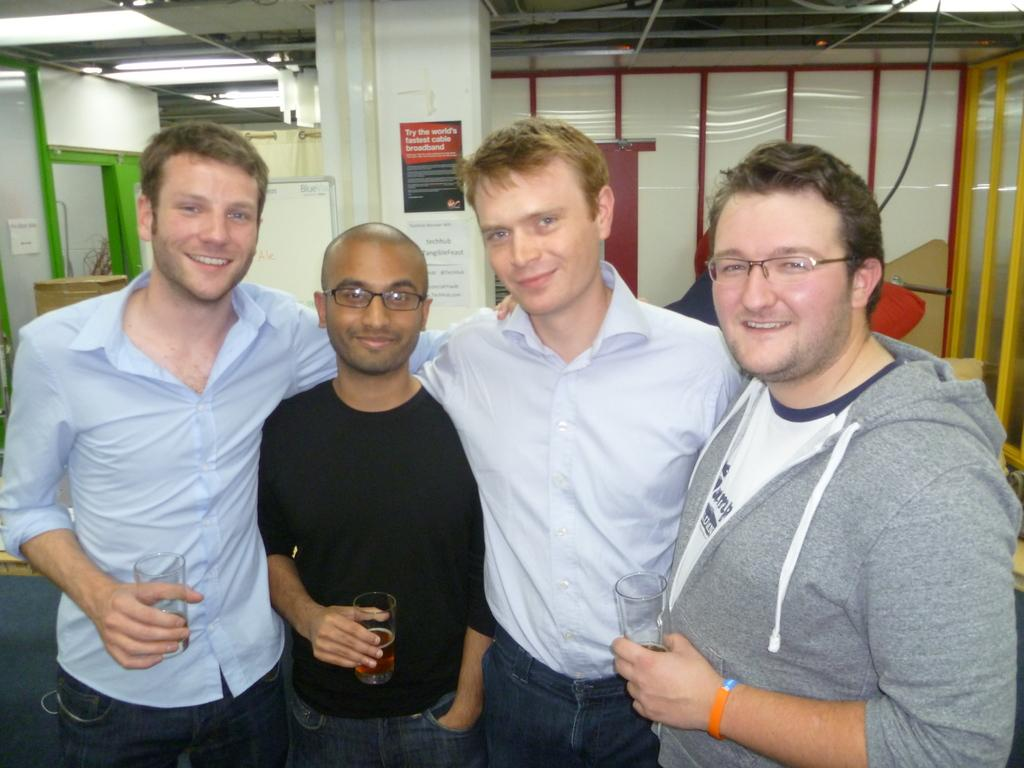What is the main subject of the image? The main subject of the image is a group of men. What are the men doing in the image? The men are standing in the image. What are the men holding in their hands? The men are holding wine glasses in the image. What can be seen in the top left corner of the image? There are ceiling lights visible in the top left corner of the image. Can you see any clouds in the image? There are no clouds present in the image. Are there any dolls visible in the image? There are no dolls present in the image. 